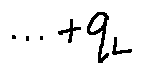Convert formula to latex. <formula><loc_0><loc_0><loc_500><loc_500>\cdots + q _ { L }</formula> 